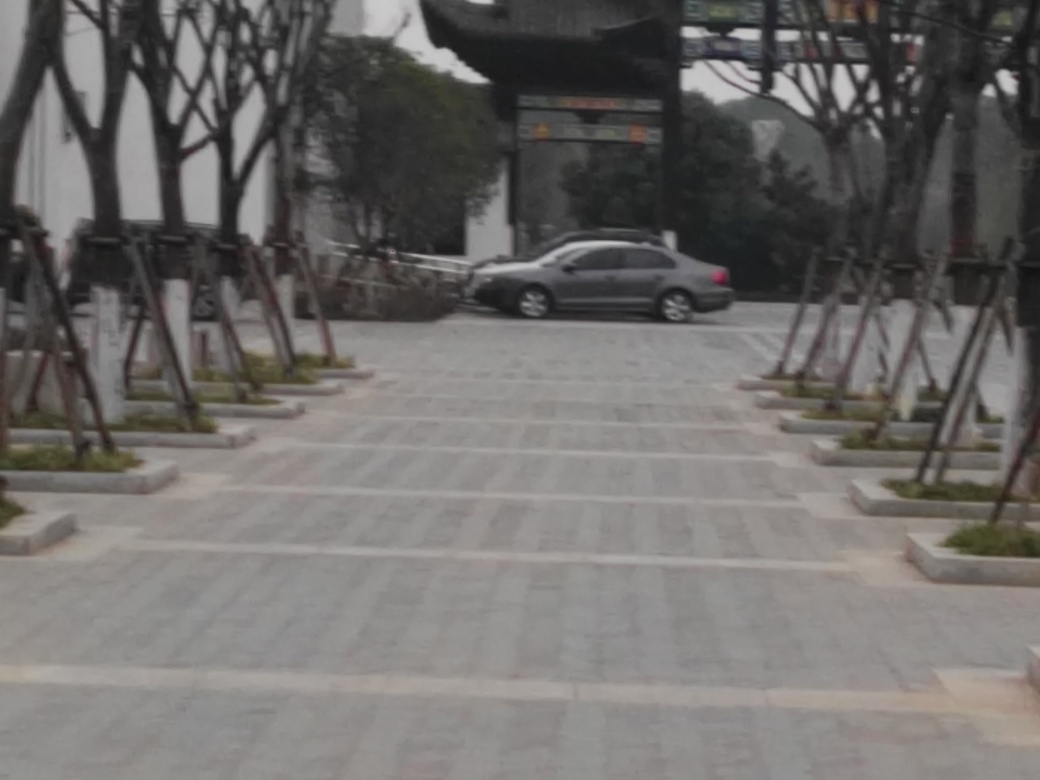What time of day does this image seem to be taken? The overcast sky and the lack of shadows suggest that the photo might have been taken either in the early morning or late afternoon. 